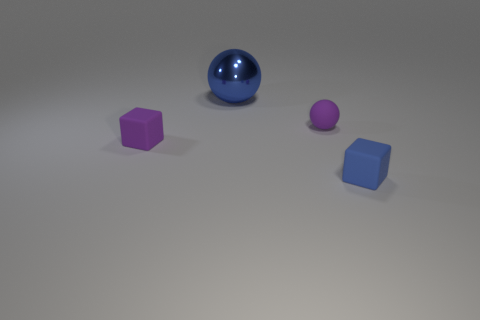There is a object that is to the right of the purple rubber cube and to the left of the purple matte ball; what shape is it?
Ensure brevity in your answer.  Sphere. There is a blue thing that is behind the tiny block that is to the left of the block that is to the right of the blue ball; what is its size?
Provide a succinct answer. Large. What is the color of the small block to the right of the big sphere?
Give a very brief answer. Blue. Are there more blue rubber objects that are to the left of the large blue metal sphere than blue rubber things?
Keep it short and to the point. No. There is a blue thing that is in front of the metallic ball; does it have the same shape as the large shiny thing?
Give a very brief answer. No. How many purple things are either small balls or small rubber things?
Give a very brief answer. 2. Is the number of big metallic spheres greater than the number of cyan shiny cylinders?
Make the answer very short. Yes. There is a rubber ball that is the same size as the blue cube; what color is it?
Offer a terse response. Purple. How many cylinders are shiny things or rubber objects?
Provide a short and direct response. 0. There is a big thing; is its shape the same as the purple object on the right side of the shiny object?
Give a very brief answer. Yes. 